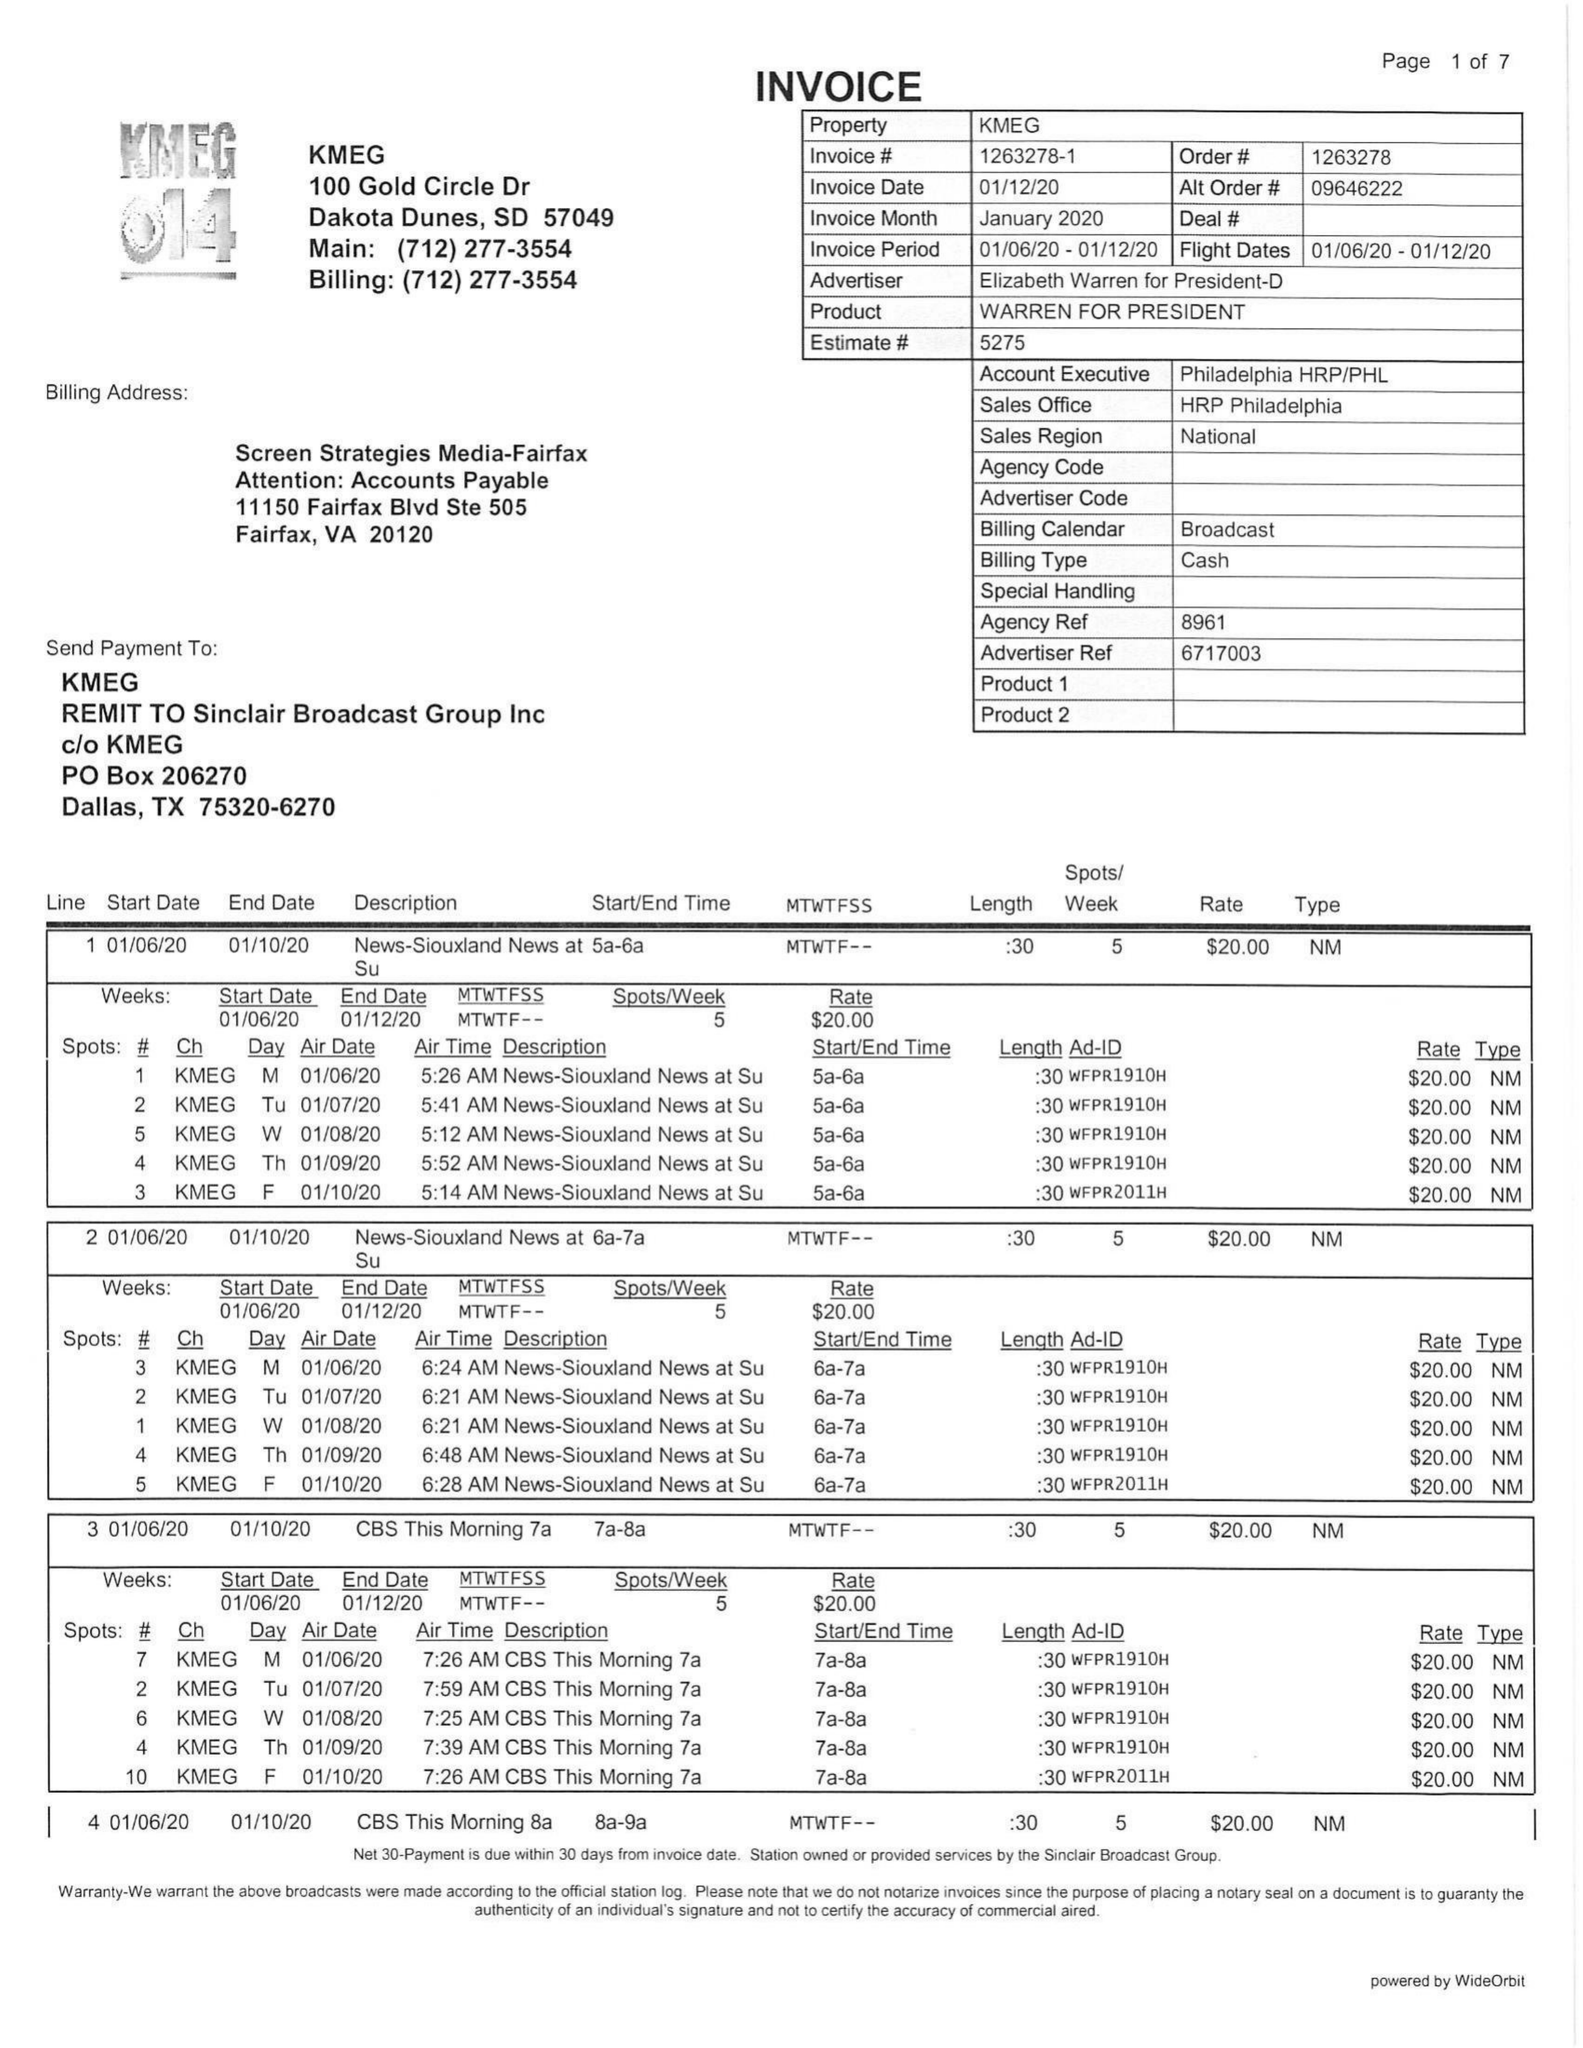What is the value for the contract_num?
Answer the question using a single word or phrase. 1263278 